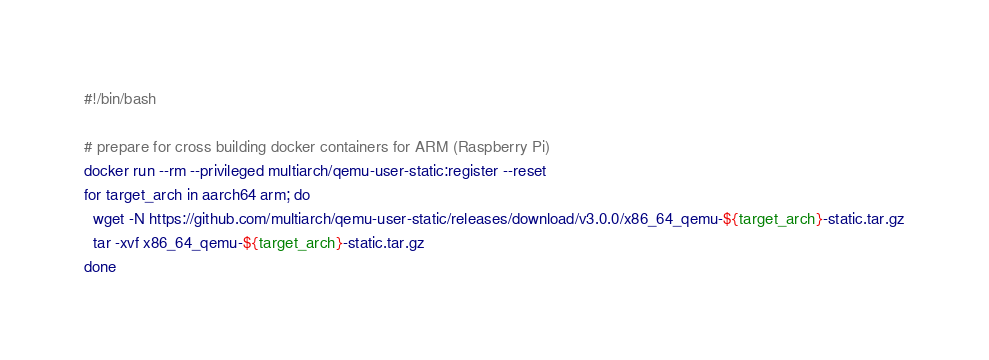<code> <loc_0><loc_0><loc_500><loc_500><_Bash_>#!/bin/bash 

# prepare for cross building docker containers for ARM (Raspberry Pi)
docker run --rm --privileged multiarch/qemu-user-static:register --reset
for target_arch in aarch64 arm; do
  wget -N https://github.com/multiarch/qemu-user-static/releases/download/v3.0.0/x86_64_qemu-${target_arch}-static.tar.gz
  tar -xvf x86_64_qemu-${target_arch}-static.tar.gz
done</code> 